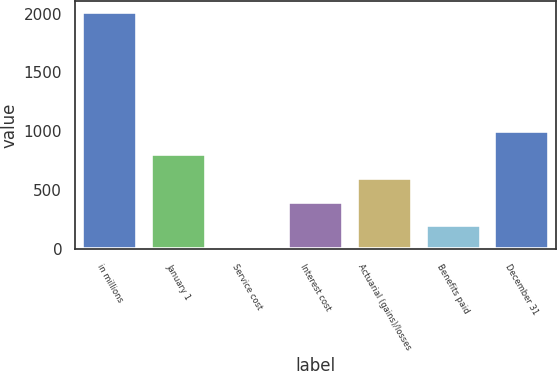Convert chart. <chart><loc_0><loc_0><loc_500><loc_500><bar_chart><fcel>in millions<fcel>January 1<fcel>Service cost<fcel>Interest cost<fcel>Actuarial (gains)/losses<fcel>Benefits paid<fcel>December 31<nl><fcel>2009<fcel>805.94<fcel>3.9<fcel>404.92<fcel>605.43<fcel>204.41<fcel>1006.45<nl></chart> 